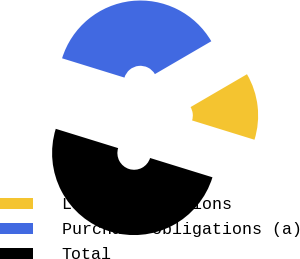<chart> <loc_0><loc_0><loc_500><loc_500><pie_chart><fcel>Lease obligations<fcel>Purchase obligations (a)<fcel>Total<nl><fcel>13.17%<fcel>36.83%<fcel>50.0%<nl></chart> 